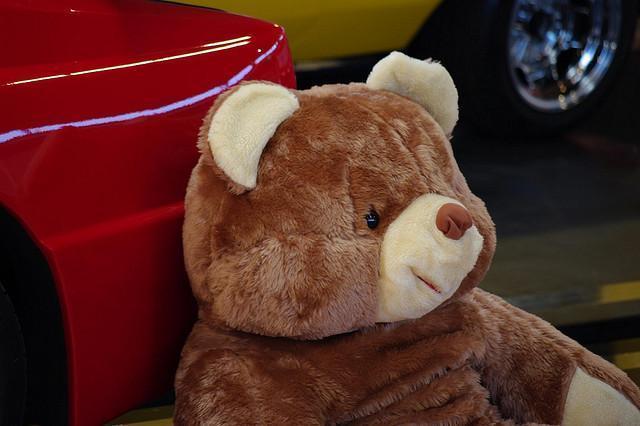How many vehicles are in back of the bear?
Give a very brief answer. 2. How many teddy bears are shown?
Give a very brief answer. 1. How many eyes does the bear have?
Give a very brief answer. 1. How many cars are visible?
Give a very brief answer. 2. How many umbrellas in this picture are yellow?
Give a very brief answer. 0. 